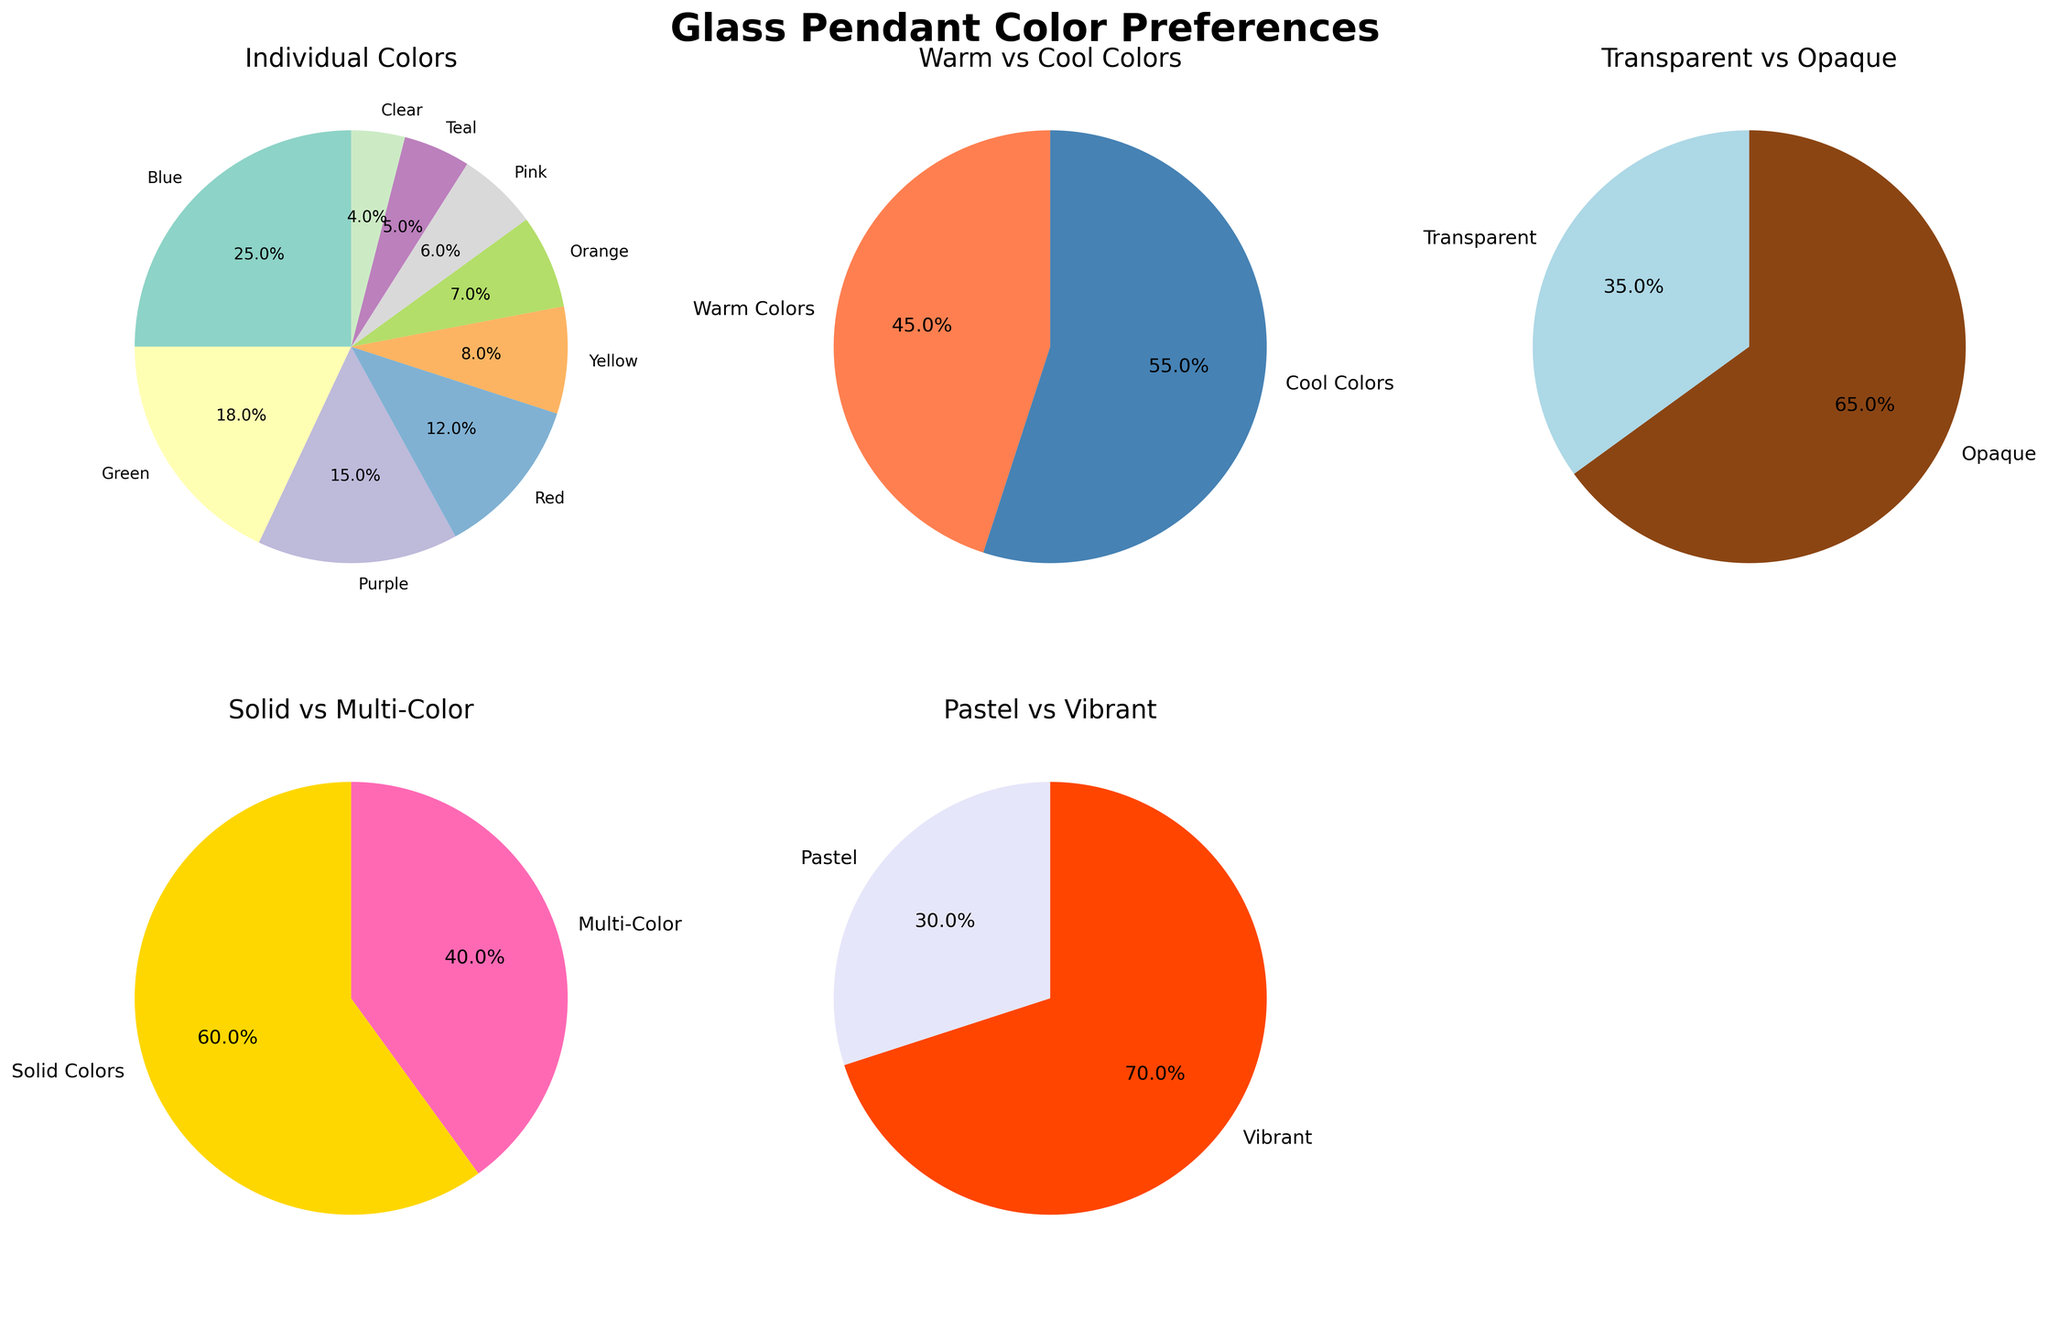What percentage of glass pendants are sold in vibrant colors? The “Pastel vs Vibrant” pie chart shows that vibrant colors are at 70%. This percentage is directly visible in the chart.
Answer: 70% How does the popularity of opaque colors compare to transparent colors? According to the "Transparent vs Opaque" pie chart, opaque colors are preferred by 65% of the customers, whereas transparent colors are only chosen by 35%. By comparing these values, we see opaque colors are more popular.
Answer: Opaque colors are more popular Which individual color is the least popular among glass pendant purchases? In the "Individual Colors" pie chart, clear is the smallest slice at 4%. This indicates that it is the least popular.
Answer: Clear Are warm colors or cool colors more popular for glass pendants? The "Warm vs Cool Colors" pie chart shows that cool colors make up 55%, whereas warm colors occupy 45%. By comparing these, we see cool colors are more popular.
Answer: Cool Colors What percentage of glass pendants are multi-colored, and how does it compare to solid colors? The "Solid vs Multi-Color" pie chart shows solid colors at 60% and multi-colored at 40%. By comparing, we see multi-colored pendants are 20% less popular than solid colors.
Answer: Multi-colored are 40%, 20% less popular 